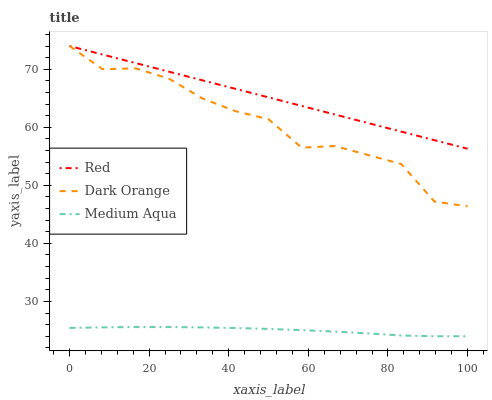Does Medium Aqua have the minimum area under the curve?
Answer yes or no. Yes. Does Red have the maximum area under the curve?
Answer yes or no. Yes. Does Red have the minimum area under the curve?
Answer yes or no. No. Does Medium Aqua have the maximum area under the curve?
Answer yes or no. No. Is Red the smoothest?
Answer yes or no. Yes. Is Dark Orange the roughest?
Answer yes or no. Yes. Is Medium Aqua the smoothest?
Answer yes or no. No. Is Medium Aqua the roughest?
Answer yes or no. No. Does Medium Aqua have the lowest value?
Answer yes or no. Yes. Does Red have the lowest value?
Answer yes or no. No. Does Red have the highest value?
Answer yes or no. Yes. Does Medium Aqua have the highest value?
Answer yes or no. No. Is Medium Aqua less than Dark Orange?
Answer yes or no. Yes. Is Red greater than Medium Aqua?
Answer yes or no. Yes. Does Red intersect Dark Orange?
Answer yes or no. Yes. Is Red less than Dark Orange?
Answer yes or no. No. Is Red greater than Dark Orange?
Answer yes or no. No. Does Medium Aqua intersect Dark Orange?
Answer yes or no. No. 